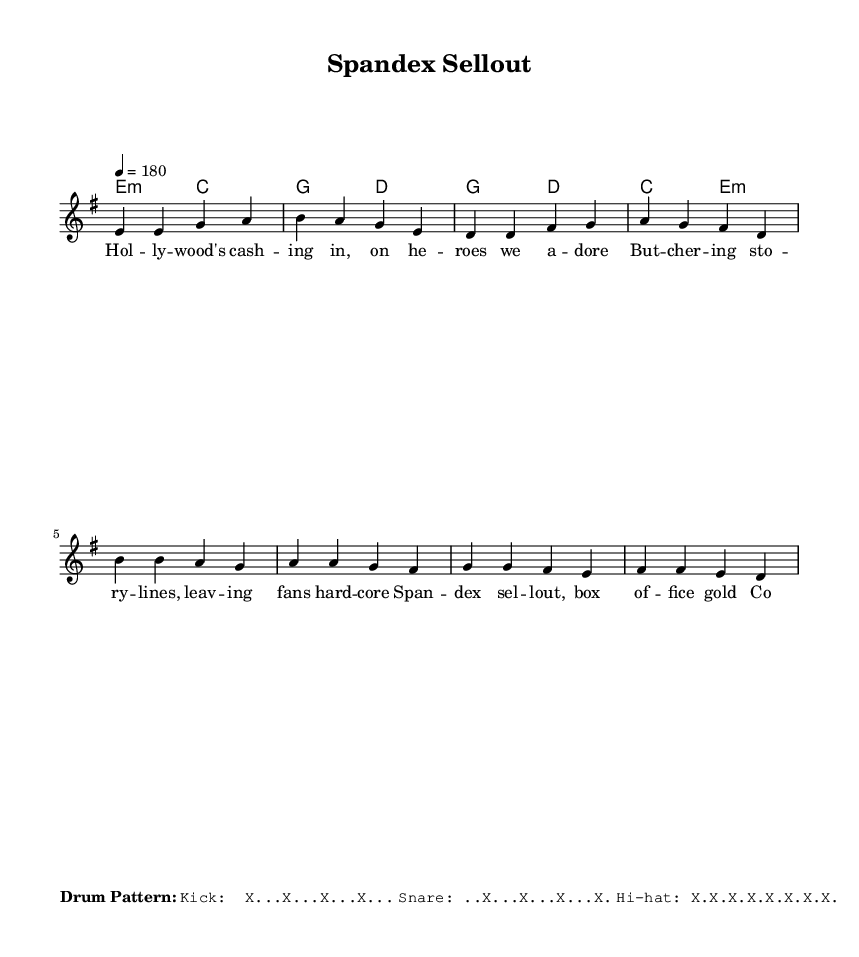What is the key signature of this music? The key signature provided in the music is E minor, as indicated by the key signature at the beginning of the score. E minor has one sharp (F#).
Answer: E minor What is the time signature of this piece? The time signature appears at the beginning of the score and is listed as 4/4, meaning four beats per measure and a quarter note gets one beat.
Answer: 4/4 What is the tempo marking for this music? The tempo marking is located at the start of the score and indicates a tempo of 180 beats per minute, set as a quarter note that plays at that speed.
Answer: 180 How many measures are in the verse section? By counting the measures in the melody for the verse, there are four measures, which is established by the structure in the sheet music.
Answer: 4 How many syllables are in the first line of the verse lyrics? The first line of the verse lyrics contains seven syllables: "Hol - ly - wood's cash - ing in, on he - roes we a - dore." Each hyphen represents a syllable.
Answer: 7 What does the title of the song suggest about its content? The title "Spandex Sellout" suggests a critique of the commercialization and mainstream adaptations of comic book characters, typical for a satirical punk song.
Answer: Critique of commercialization What are the instruments indicated in the score? The score does not provide specific instrumentation, but it shows a staff for the lead vocal and chord names indicating implied chords for accompaniment.
Answer: Lead vocal and chords 